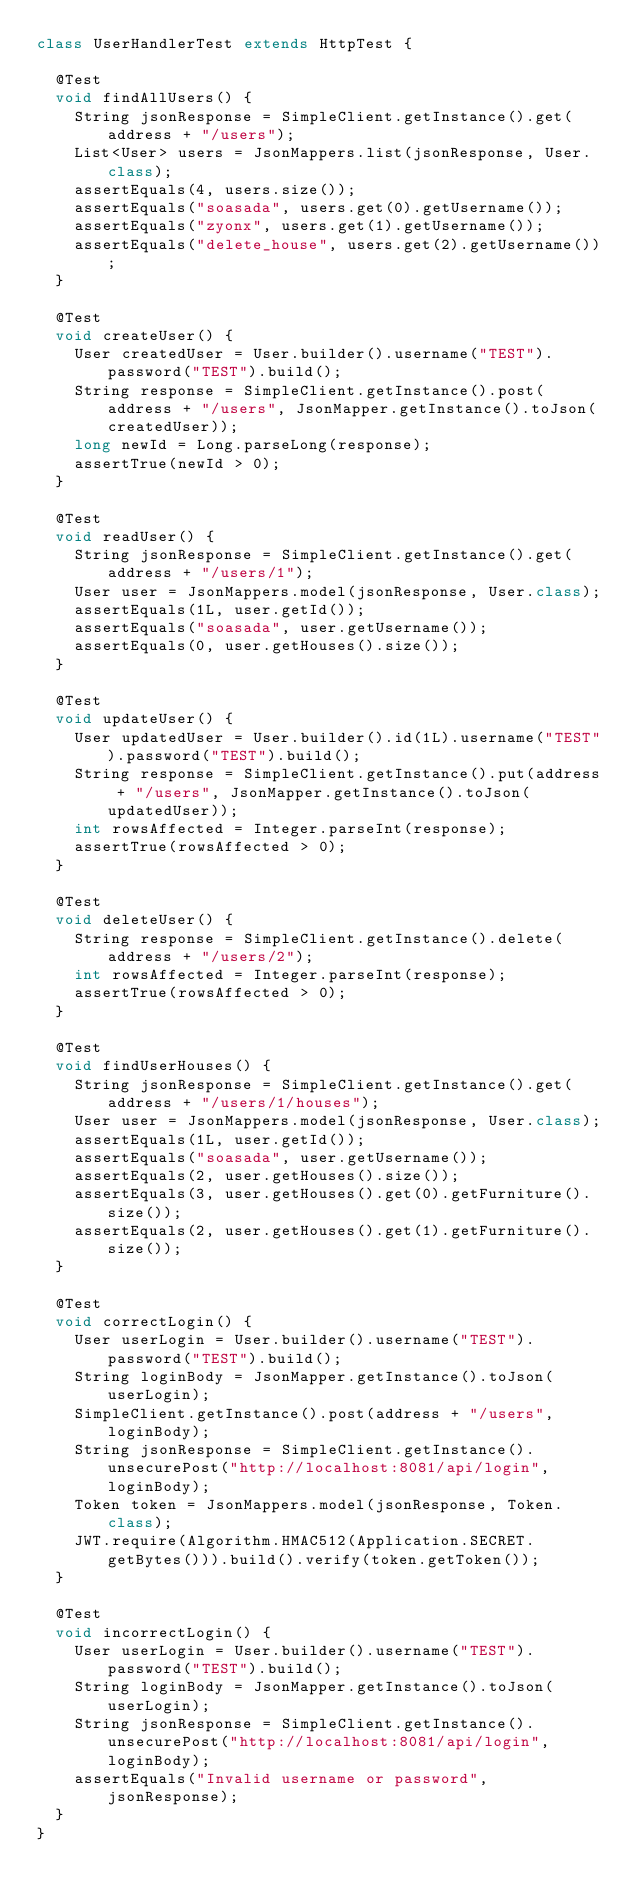<code> <loc_0><loc_0><loc_500><loc_500><_Java_>class UserHandlerTest extends HttpTest {

  @Test
  void findAllUsers() {
    String jsonResponse = SimpleClient.getInstance().get(address + "/users");
    List<User> users = JsonMappers.list(jsonResponse, User.class);
    assertEquals(4, users.size());
    assertEquals("soasada", users.get(0).getUsername());
    assertEquals("zyonx", users.get(1).getUsername());
    assertEquals("delete_house", users.get(2).getUsername());
  }

  @Test
  void createUser() {
    User createdUser = User.builder().username("TEST").password("TEST").build();
    String response = SimpleClient.getInstance().post(address + "/users", JsonMapper.getInstance().toJson(createdUser));
    long newId = Long.parseLong(response);
    assertTrue(newId > 0);
  }

  @Test
  void readUser() {
    String jsonResponse = SimpleClient.getInstance().get(address + "/users/1");
    User user = JsonMappers.model(jsonResponse, User.class);
    assertEquals(1L, user.getId());
    assertEquals("soasada", user.getUsername());
    assertEquals(0, user.getHouses().size());
  }

  @Test
  void updateUser() {
    User updatedUser = User.builder().id(1L).username("TEST").password("TEST").build();
    String response = SimpleClient.getInstance().put(address + "/users", JsonMapper.getInstance().toJson(updatedUser));
    int rowsAffected = Integer.parseInt(response);
    assertTrue(rowsAffected > 0);
  }

  @Test
  void deleteUser() {
    String response = SimpleClient.getInstance().delete(address + "/users/2");
    int rowsAffected = Integer.parseInt(response);
    assertTrue(rowsAffected > 0);
  }

  @Test
  void findUserHouses() {
    String jsonResponse = SimpleClient.getInstance().get(address + "/users/1/houses");
    User user = JsonMappers.model(jsonResponse, User.class);
    assertEquals(1L, user.getId());
    assertEquals("soasada", user.getUsername());
    assertEquals(2, user.getHouses().size());
    assertEquals(3, user.getHouses().get(0).getFurniture().size());
    assertEquals(2, user.getHouses().get(1).getFurniture().size());
  }

  @Test
  void correctLogin() {
    User userLogin = User.builder().username("TEST").password("TEST").build();
    String loginBody = JsonMapper.getInstance().toJson(userLogin);
    SimpleClient.getInstance().post(address + "/users", loginBody);
    String jsonResponse = SimpleClient.getInstance().unsecurePost("http://localhost:8081/api/login", loginBody);
    Token token = JsonMappers.model(jsonResponse, Token.class);
    JWT.require(Algorithm.HMAC512(Application.SECRET.getBytes())).build().verify(token.getToken());
  }

  @Test
  void incorrectLogin() {
    User userLogin = User.builder().username("TEST").password("TEST").build();
    String loginBody = JsonMapper.getInstance().toJson(userLogin);
    String jsonResponse = SimpleClient.getInstance().unsecurePost("http://localhost:8081/api/login", loginBody);
    assertEquals("Invalid username or password", jsonResponse);
  }
}</code> 